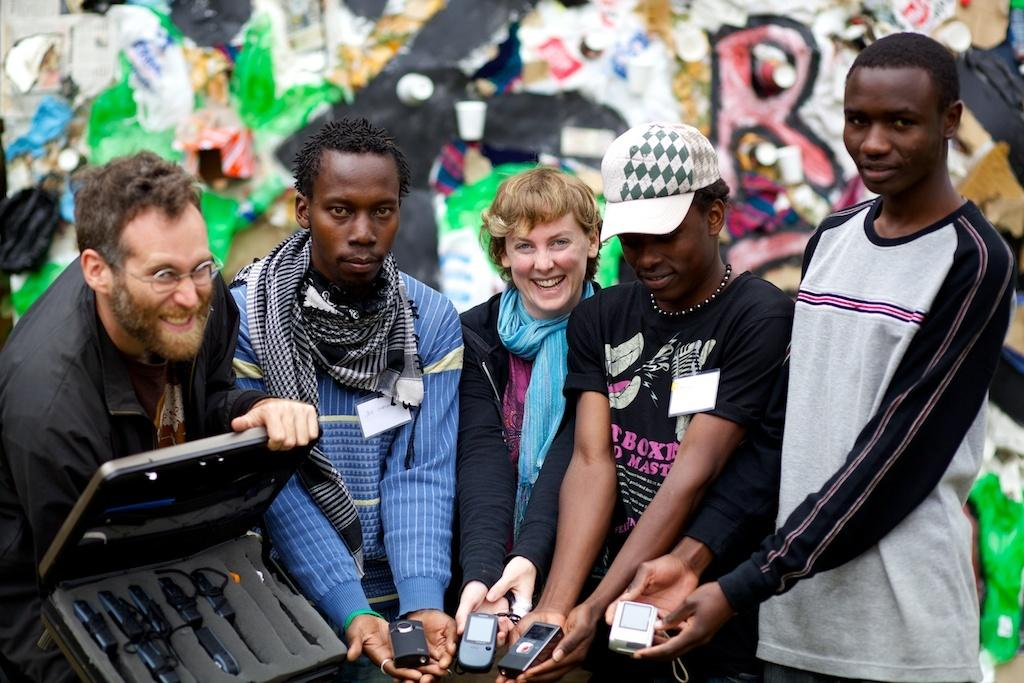How many people are in the image? There are people in the image, but the exact number is not specified. What are some of the people holding in the image? Four of the people are holding cameras, and one person is holding a suitcase. What can be seen in the background of the image? There is a wall visible in the background of the image. What time is the doctor scheduled to arrive in the image? There is no mention of a doctor or a scheduled arrival time in the image. 